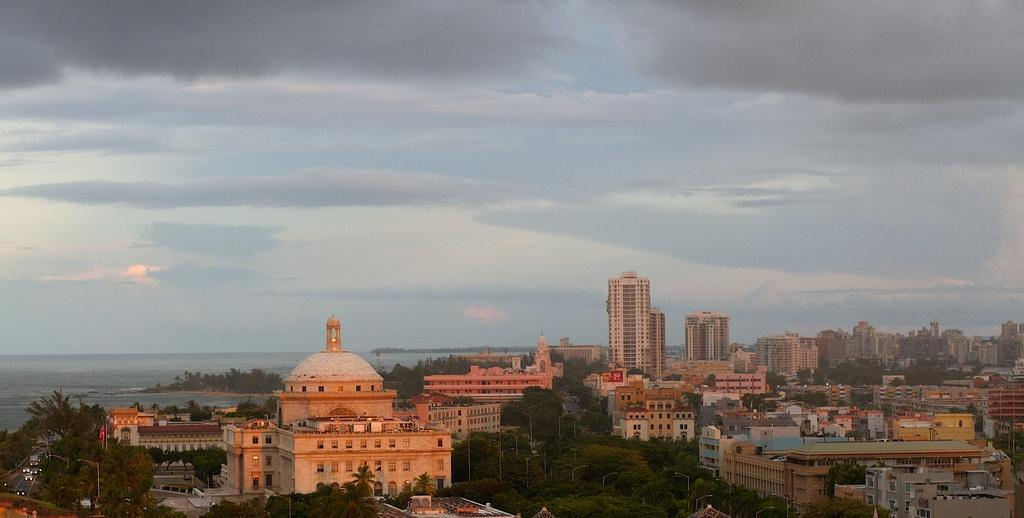What type of structures can be seen in the image? There are buildings in the image. What other natural elements are present in the image? There are trees and water visible in the image. What is visible in the background of the image? The sky is visible in the background of the image. How would you describe the sky in the image? The sky appears to be cloudy. What type of alarm can be heard going off in the image? There is no alarm present in the image, and therefore no sound can be heard. 